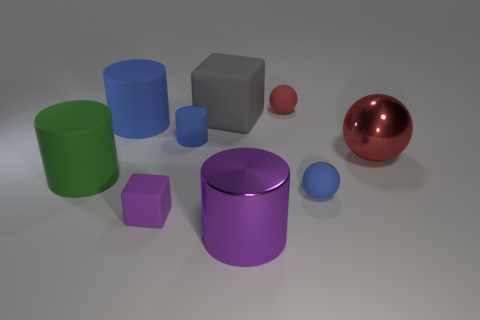Are there any other things of the same color as the tiny block?
Keep it short and to the point. Yes. How many things are red metal objects or tiny green balls?
Ensure brevity in your answer.  1. What size is the matte object that is the same color as the large metallic cylinder?
Provide a succinct answer. Small. There is a big blue matte cylinder; are there any big green objects in front of it?
Provide a short and direct response. Yes. Is the number of matte objects that are in front of the big purple thing greater than the number of small blue rubber spheres behind the green thing?
Your answer should be compact. No. There is a metal object that is the same shape as the red matte object; what size is it?
Offer a very short reply. Large. What number of spheres are purple things or large red shiny objects?
Your answer should be very brief. 1. There is a big thing that is the same color as the tiny cube; what is its material?
Your answer should be compact. Metal. Are there fewer small red objects on the right side of the red metallic thing than big cylinders left of the red rubber object?
Offer a terse response. Yes. What number of things are objects in front of the green rubber thing or large purple metallic cylinders?
Your answer should be compact. 3. 